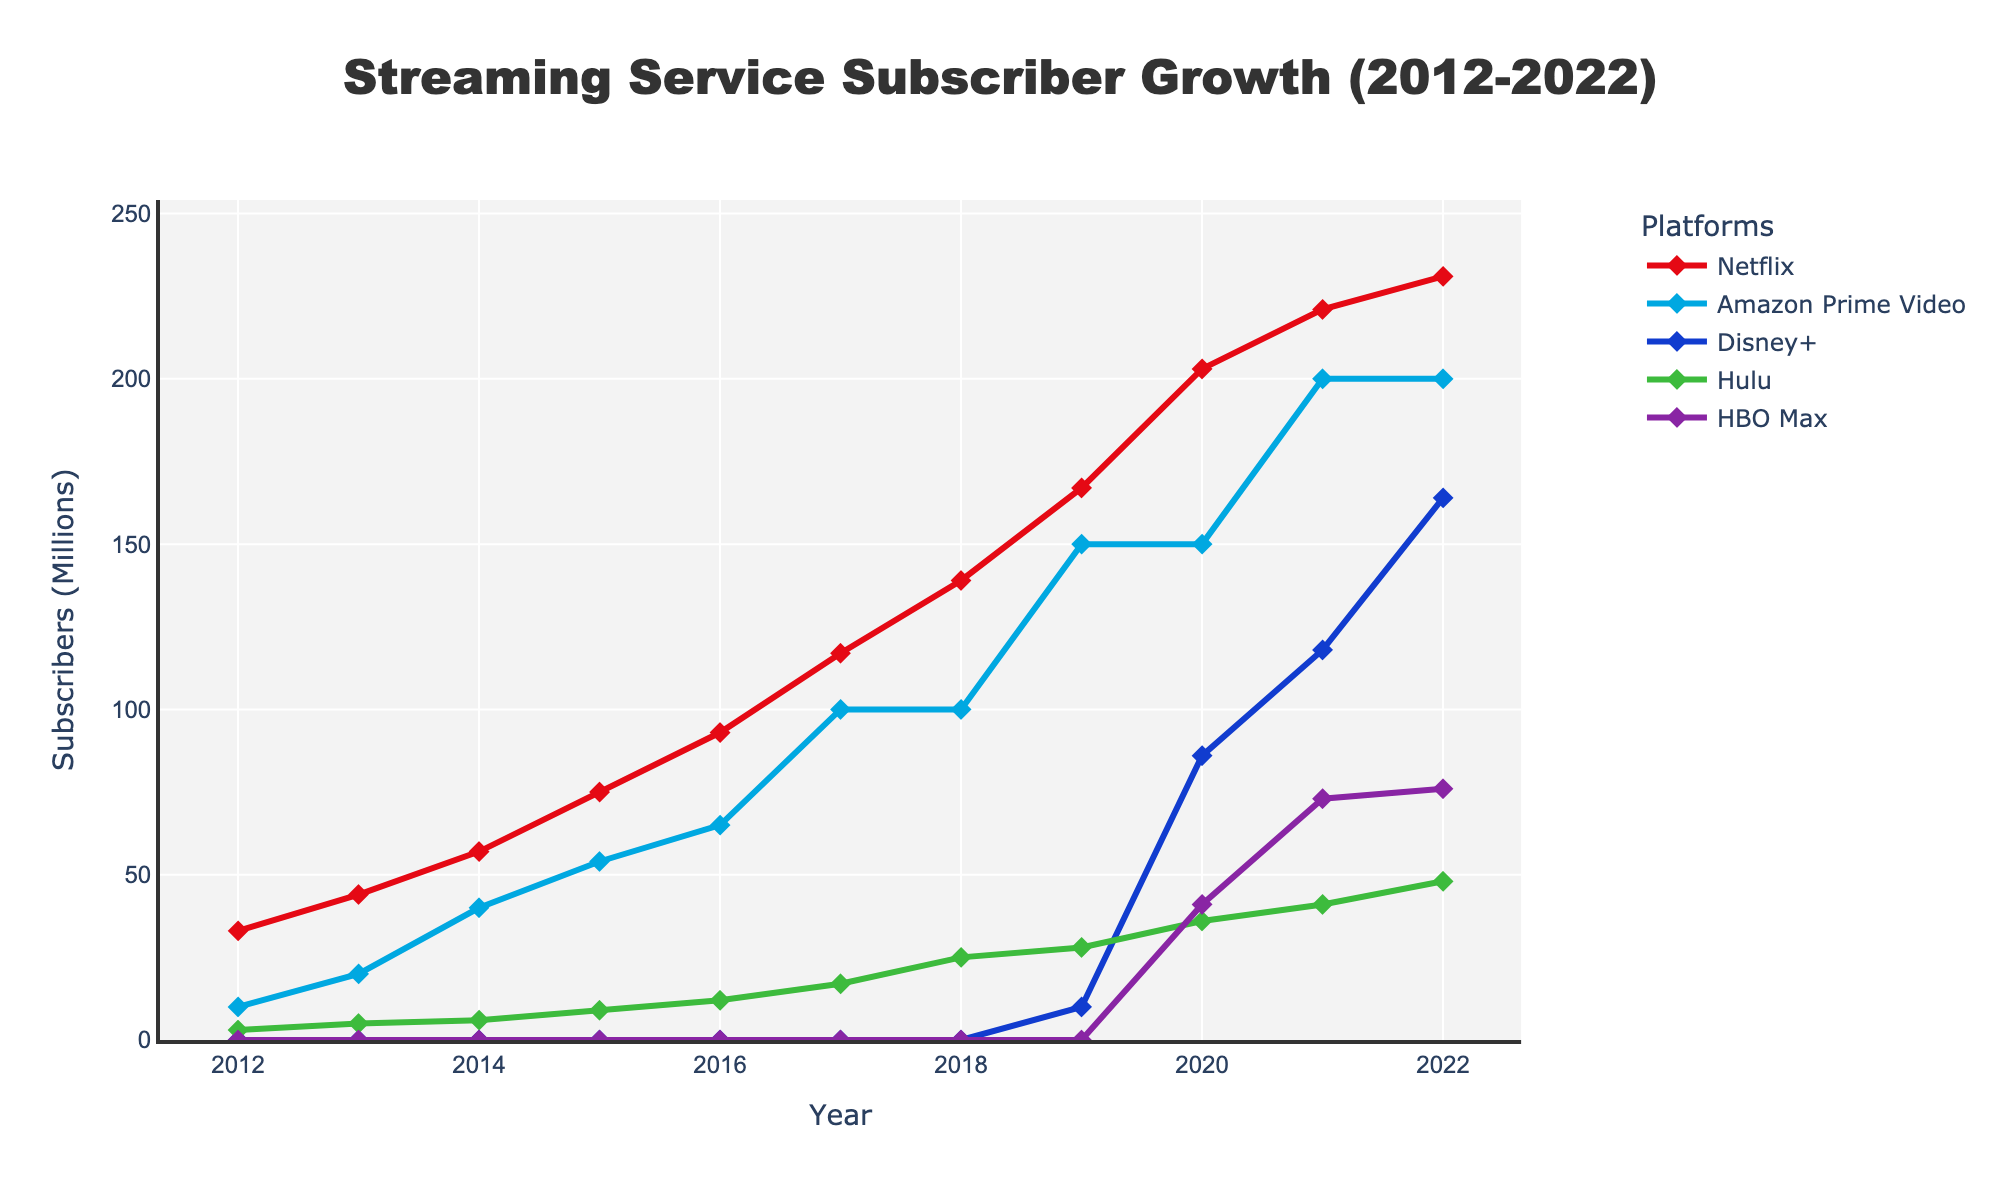What's the subscriber growth for Netflix from 2012 to 2022? To calculate the growth, subtract the number of subscribers in 2012 from the number of subscribers in 2022. So, it's 231 (in 2022) - 33 (in 2012) = 198 million.
Answer: 198 million Which platform saw the fastest growth between 2019 and 2020? Look at the slopes of the lines between 2019 and 2020. Disney+ went from 10 to 86 million, an increase of 76 million, which is the largest gain among the platforms in this period.
Answer: Disney+ How many platforms reached over 100 million subscribers by 2022? By 2022, the platforms with over 100 million subscribers are Netflix (231 million), Amazon Prime Video (200 million), and Disney+ (164 million). Count them: 3 platforms.
Answer: 3 Compare the subscriber count of Hulu and HBO Max in 2021. Which had more, and by how much? In 2021, Hulu had 41 million and HBO Max had 73 million subscribers. Subtract Hulu's subscribers from HBO Max's: 73 - 41 = 32 million.
Answer: HBO Max by 32 million What's the general trend for Amazon Prime Video subscribers from 2012 to 2022? Examine the curve for Amazon Prime Video. It shows a steady upward trend starting from 10 million in 2012 and reaching 200 million in 2022.
Answer: Steady upward How did Disney+'s subscribers in its first year compare with Hulu's subscribers in 2019? Disney+ had 10 million subscribers in its first year (2019) and Hulu had 28 million in 2019. Compare these values to find that Hulu had 18 million more subscribers than Disney+ in 2019.
Answer: Hulu had 18 million more What was the total number of subscribers for all platforms combined in 2022? Sum the subscribers of all platforms in 2022: 231 (Netflix) + 200 (Amazon Prime Video) + 164 (Disney+) + 48 (Hulu) + 76 (HBO Max) = 719 million.
Answer: 719 million In which year did Netflix surpass 100 million subscribers? Check the figure for when Netflix's line crosses the 100 million mark. This happens between 2016 (93 million) and 2017 (117 million), thus in 2017.
Answer: 2017 Compare the overall trend in subscriber numbers for Hulu and Netflix from 2012 to 2022. Look at the slope and intercept of both lines. Netflix shows a sharp, consistent increase, while Hulu shows a slower, steadier rise.
Answer: Netflix is sharper, Hulu is steadier 